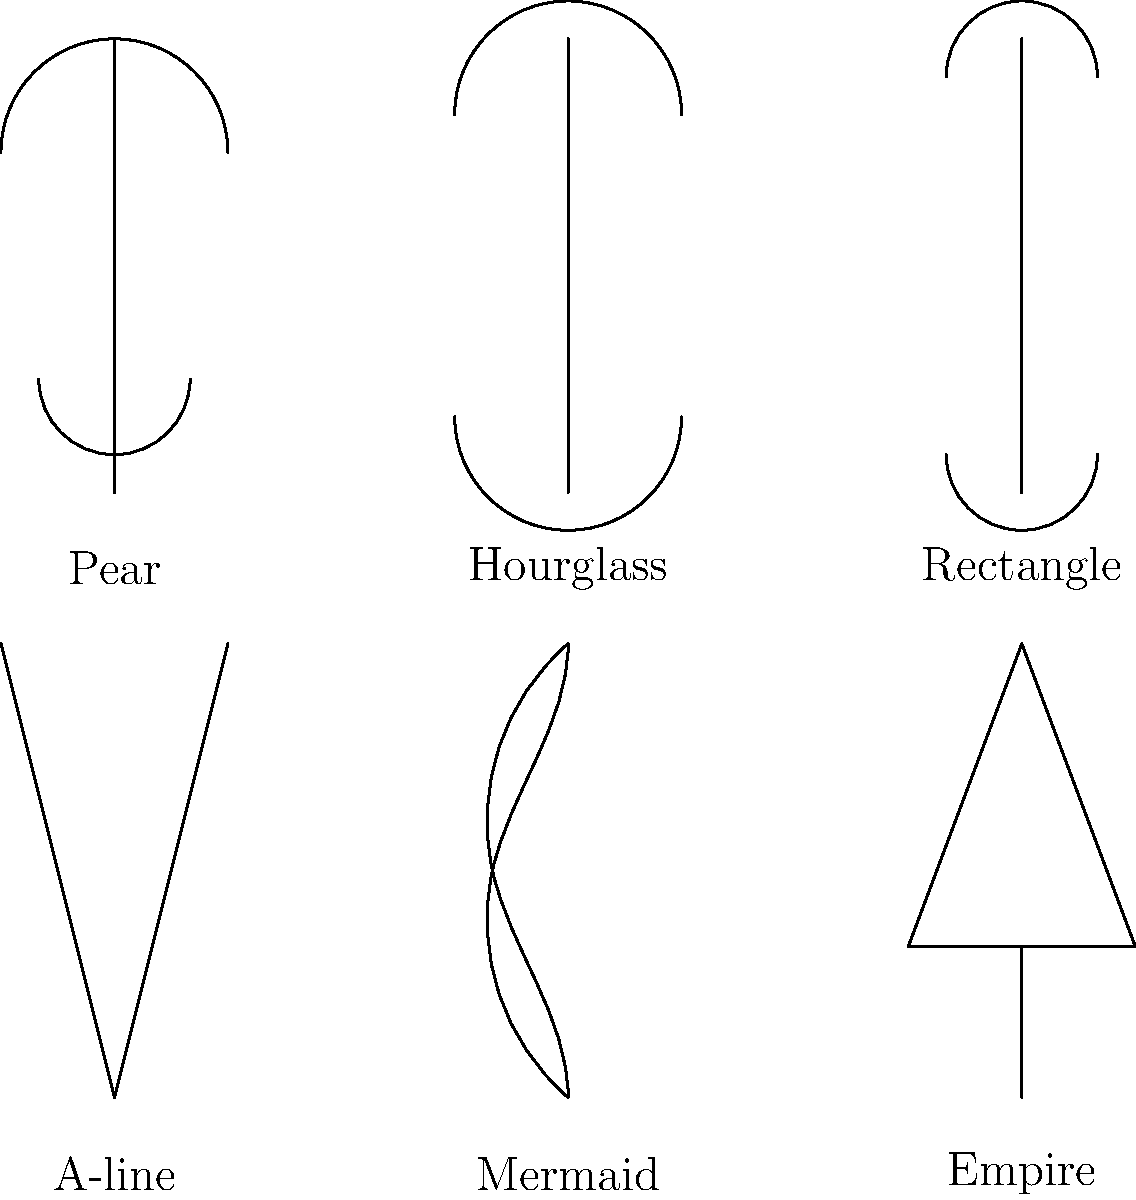Match the evening gown styles to the body types that they best flatter. Which style is most suitable for a pear-shaped body? To determine the best evening gown style for a pear-shaped body, let's analyze each style and body type:

1. Pear-shaped body:
   - Wider hips and thighs
   - Narrower shoulders and bust

2. A-line dress:
   - Fitted at the bodice
   - Gradually widens from the waist down
   - Creates balance by emphasizing the upper body and skimming over the hips

3. Mermaid dress:
   - Fitted through the bodice, hips, and thighs
   - Flares out at or below the knees
   - Emphasizes curves, which may accentuate the pear shape

4. Empire dress:
   - High waistline just below the bust
   - Loose, flowing skirt
   - De-emphasizes the lower body

For a pear-shaped body, the goal is to balance the proportions by drawing attention to the upper body and minimizing focus on the hips and thighs.

The A-line dress is the most suitable option because:
- It fits well at the bodice, highlighting the narrower upper body
- The gradual widening of the skirt smoothly covers the hips and thighs without clinging
- It creates a balanced silhouette that complements the pear shape

The mermaid style, while flattering for some body types, may overemphasize the hips and thighs of a pear-shaped figure.

The empire style could be a good second choice, as it draws attention to the bust and flows over the lower body. However, the A-line provides a more defined waistline, which can be flattering for many pear-shaped individuals.
Answer: A-line dress 